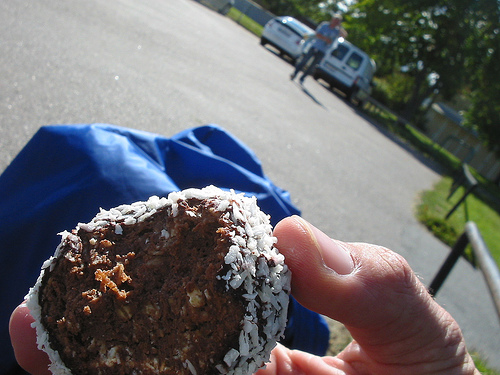<image>
Is there a man on the van? No. The man is not positioned on the van. They may be near each other, but the man is not supported by or resting on top of the van. 